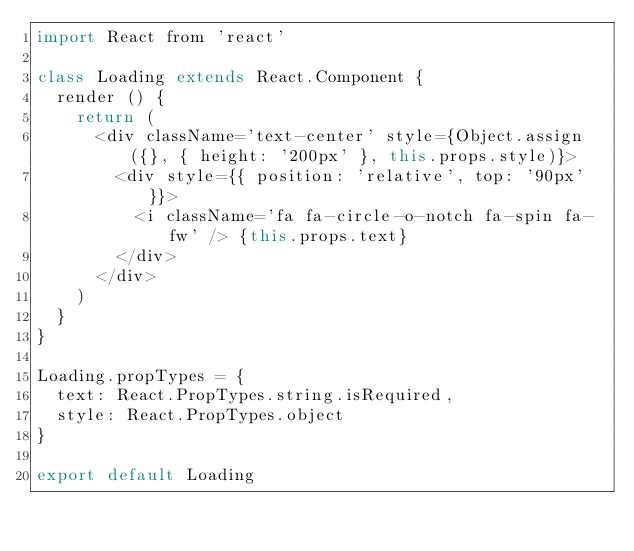Convert code to text. <code><loc_0><loc_0><loc_500><loc_500><_JavaScript_>import React from 'react'

class Loading extends React.Component {
  render () {
    return (
      <div className='text-center' style={Object.assign({}, { height: '200px' }, this.props.style)}>
        <div style={{ position: 'relative', top: '90px' }}>
          <i className='fa fa-circle-o-notch fa-spin fa-fw' /> {this.props.text}
        </div>
      </div>
    )
  }
}

Loading.propTypes = {
  text: React.PropTypes.string.isRequired,
  style: React.PropTypes.object
}

export default Loading
</code> 